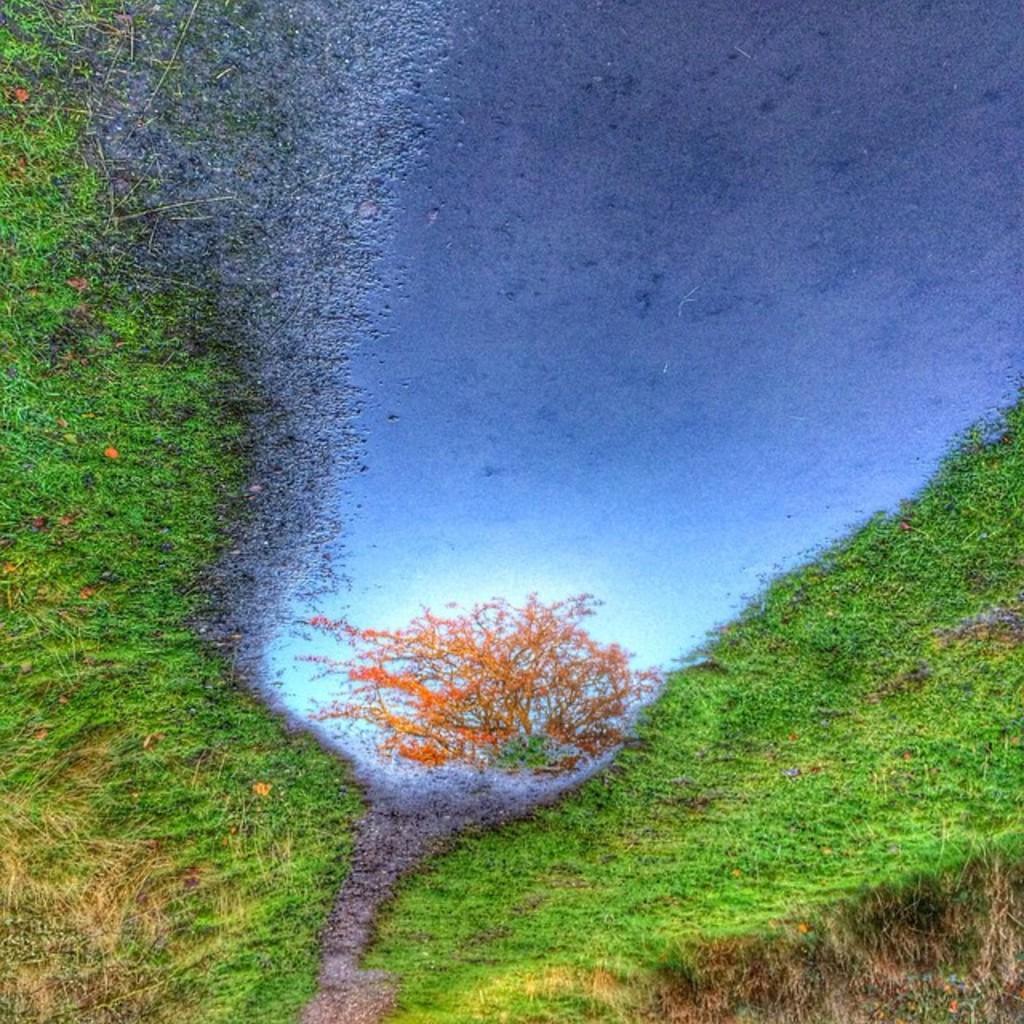Could you give a brief overview of what you see in this image? In this image I can see the art of grass and the water. In the water I can see the reflection of tree and the sky. 